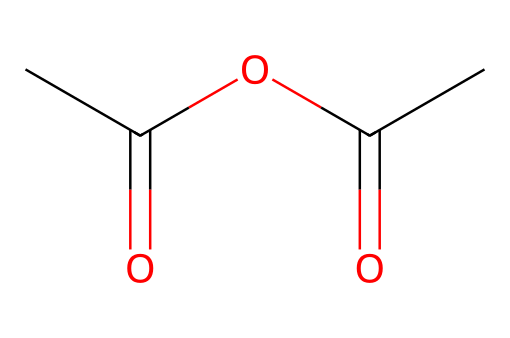What is the molecular formula of this compound? By analyzing the SMILES representation CC(=O)OC(=O)C, we can count the number of carbon (C), hydrogen (H), and oxygen (O) atoms. There are 4 carbon atoms, 6 hydrogen atoms, and 3 oxygen atoms. Thus, the molecular formula is C4H6O3.
Answer: C4H6O3 How many carbon atoms are present in this molecule? The SMILES representation shows four distinct carbon symbols (C), indicating that there are 4 carbon atoms in total in the compound.
Answer: 4 Is this compound hydrophilic or hydrophobic? The presence of the carboxylic acid groups as indicated by the functional groups (–CO) suggests that the compound can interact with water and is more likely to be hydrophilic.
Answer: hydrophilic What type of chemical is acetic anhydride? Acetic anhydride is classified as an acid anhydride. Based on its structure, which consists of two acetic acid units minus a water molecule, it fits the definition of an acid anhydride.
Answer: acid anhydride What is the role of acetic anhydride in treating wooden instrument parts? Acetic anhydride acts as a wood preservative by modifying the cellulose structure in wood, which can enhance durability and resistance to moisture. This functional modification is beneficial for wooden instrument longevity.
Answer: wood preservative How many functional groups are present in acetic anhydride? In examining the structure, there are two carbonyl groups (C=O), which are characteristic of acid anhydrides, resulting in one functional group type within this molecule.
Answer: one functional group 